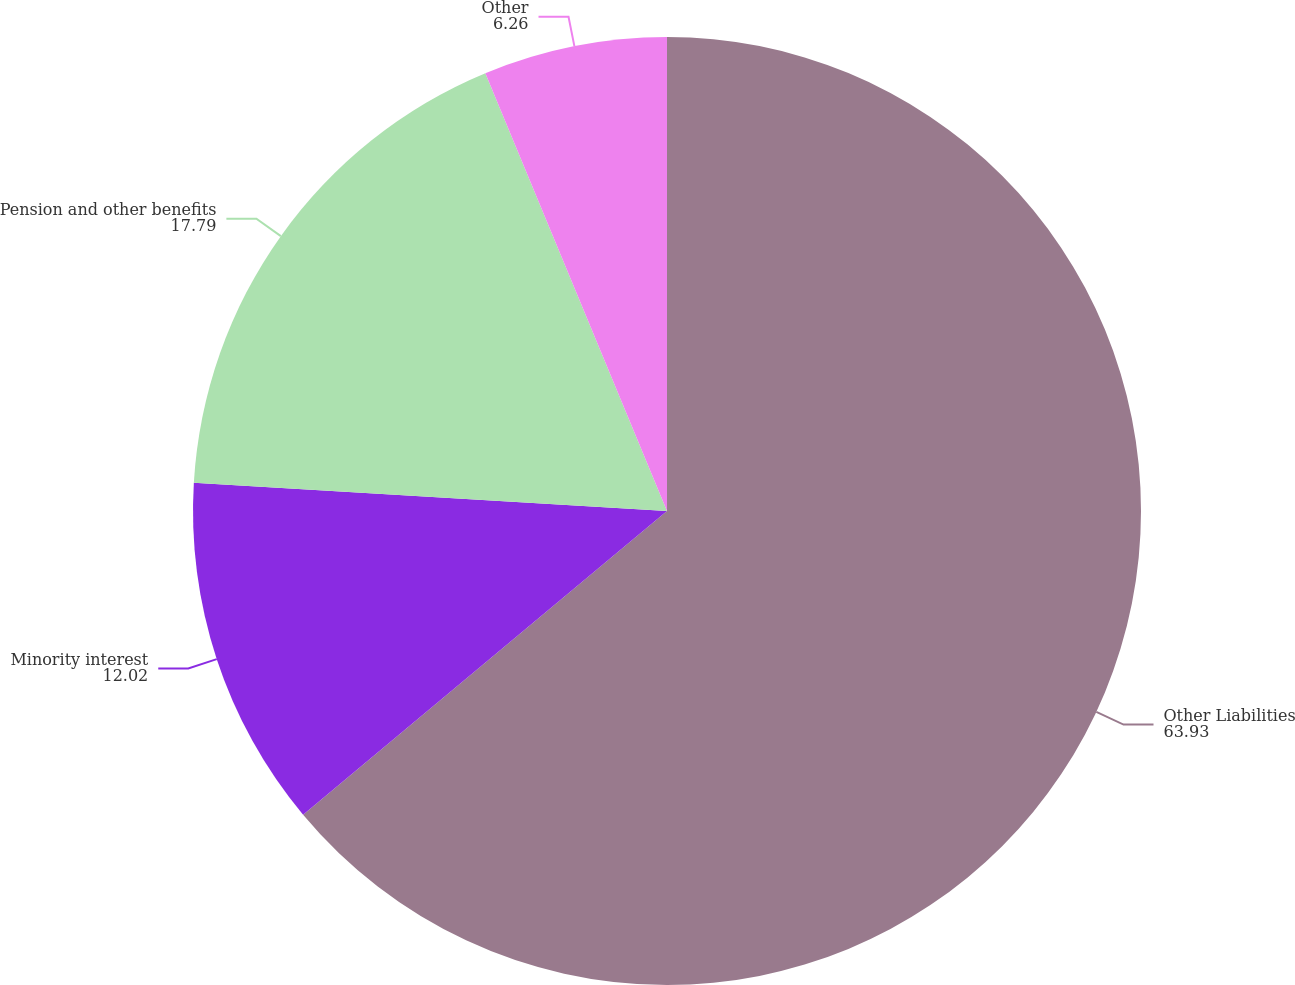<chart> <loc_0><loc_0><loc_500><loc_500><pie_chart><fcel>Other Liabilities<fcel>Minority interest<fcel>Pension and other benefits<fcel>Other<nl><fcel>63.93%<fcel>12.02%<fcel>17.79%<fcel>6.26%<nl></chart> 